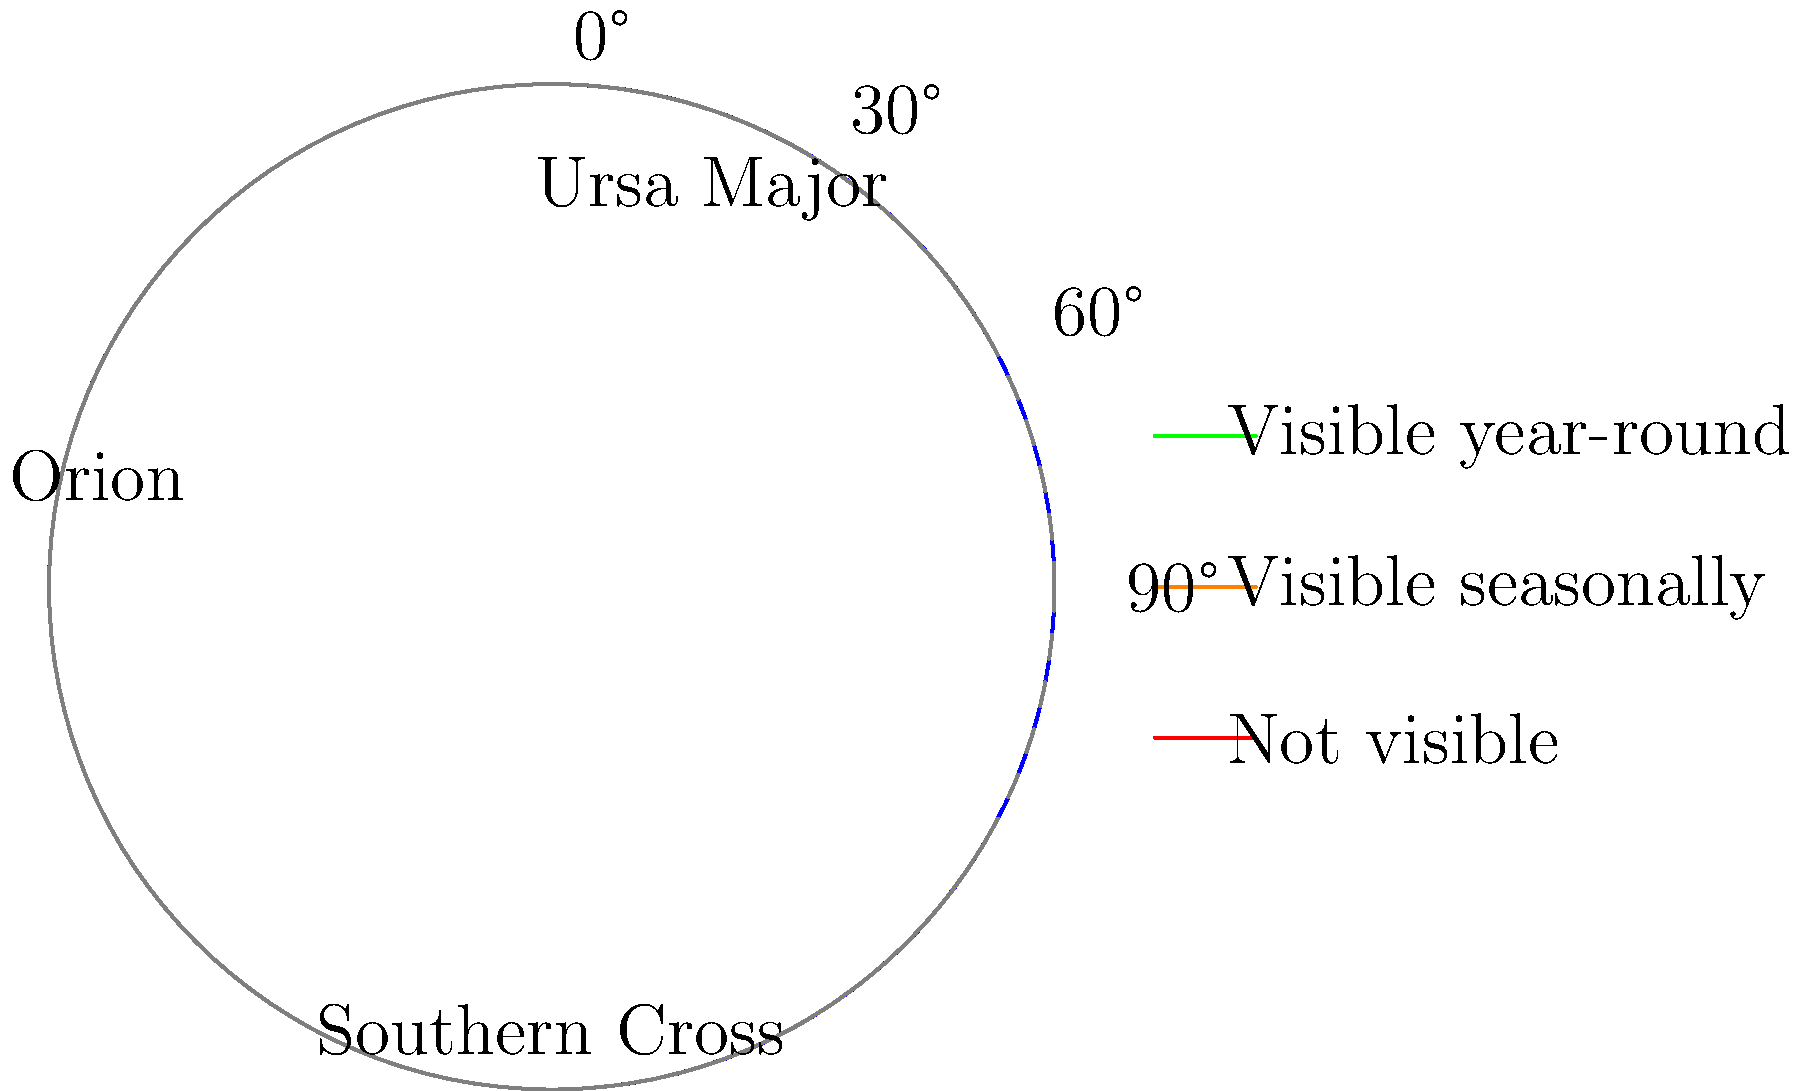During a night rescue operation, you need to use celestial navigation. Which of the constellations shown would be visible year-round from your current latitude of 45°N? To determine which constellation is visible year-round from 45°N latitude, we need to consider the following steps:

1. Understand the relationship between latitude and visible constellations:
   - Constellations that are always above the horizon at a given latitude are visible year-round.
   - The altitude of the celestial north pole equals the observer's latitude.

2. Calculate the declination range for year-round visibility at 45°N:
   - Constellations with declinations greater than (90° - latitude) will be circumpolar.
   - For 45°N: 90° - 45° = 45°
   - Constellations with declinations > +45° will be visible year-round.

3. Analyze the constellations shown in the diagram:
   - Ursa Major: Located near the celestial north pole, declination around +55°.
   - Orion: Located near the celestial equator, declination around 0°.
   - Southern Cross: Located in the southern sky, declination around -60°.

4. Compare the constellations' declinations to the calculated threshold:
   - Ursa Major: +55° > +45°, visible year-round.
   - Orion: 0° < +45°, not visible year-round (seasonally visible).
   - Southern Cross: -60° < +45°, not visible from 45°N.

Therefore, among the constellations shown, only Ursa Major would be visible year-round from 45°N latitude.
Answer: Ursa Major 